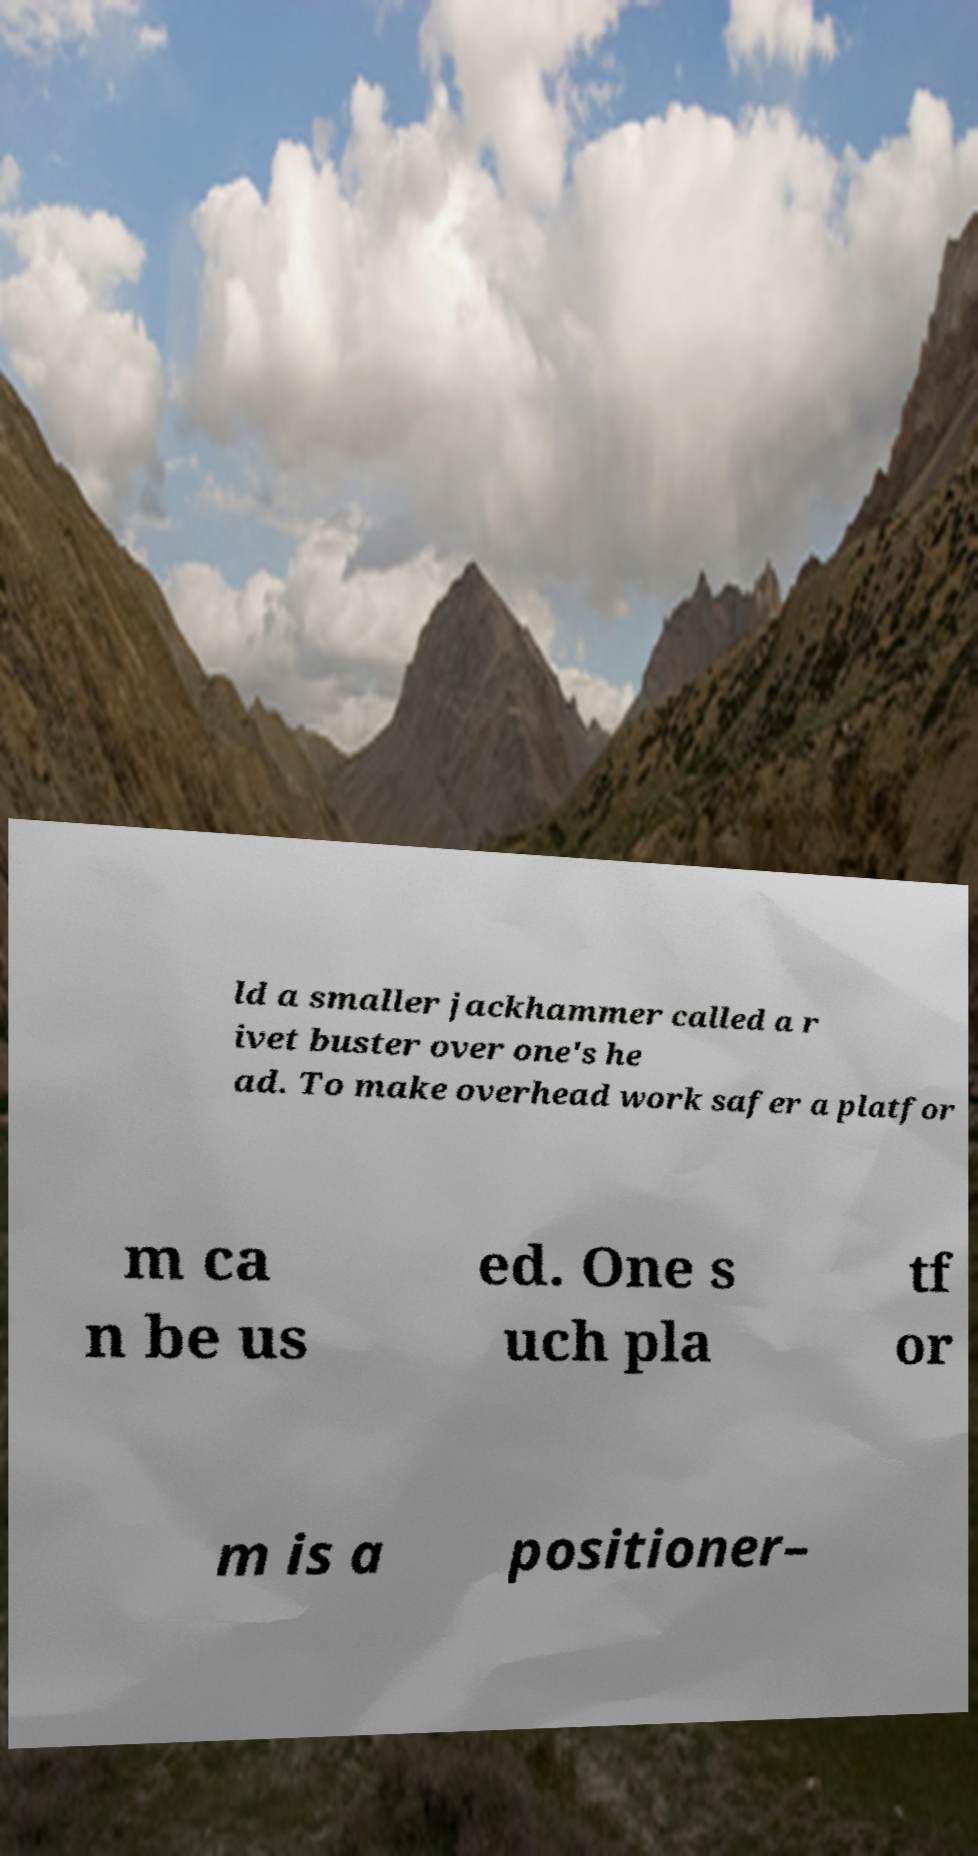I need the written content from this picture converted into text. Can you do that? ld a smaller jackhammer called a r ivet buster over one's he ad. To make overhead work safer a platfor m ca n be us ed. One s uch pla tf or m is a positioner– 